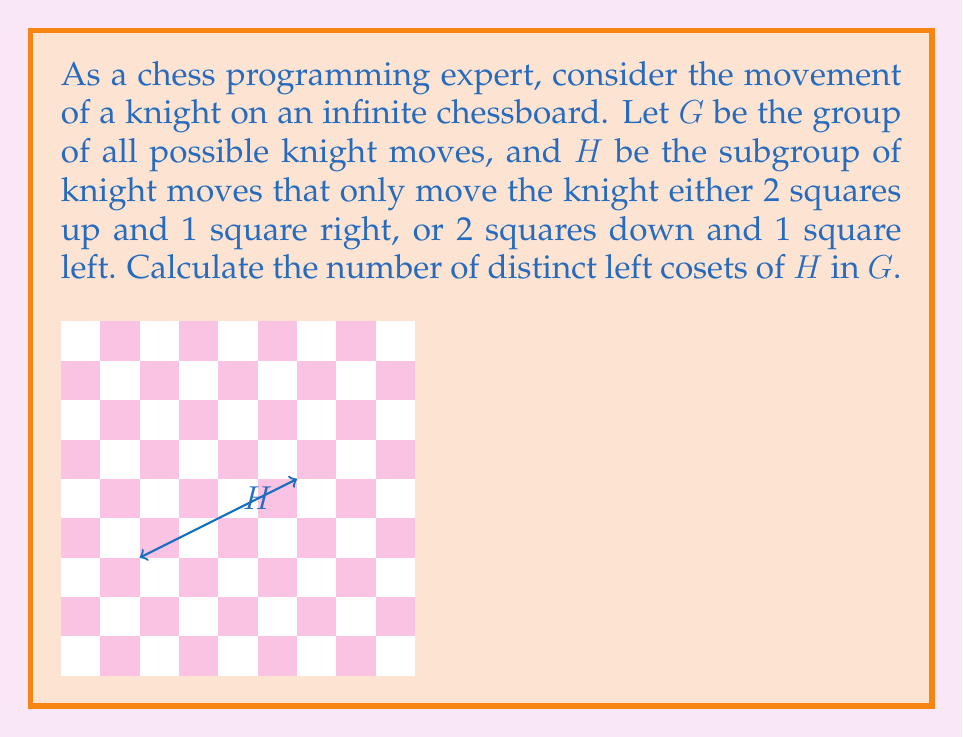Can you answer this question? Let's approach this step-by-step:

1) First, we need to understand the structure of the group G and the subgroup H:
   - G consists of all possible knight moves (8 in total)
   - H consists of only 2 specific moves

2) The number of distinct left cosets is equal to the index of H in G, denoted as [G:H].

3) By Lagrange's theorem, we know that:

   $$[G:H] = \frac{|G|}{|H|}$$

   where |G| is the order of G and |H| is the order of H.

4) Let's calculate |G| and |H|:
   - |G| = 8 (total number of knight moves)
   - |H| = 2 (number of moves in the subgroup)

5) Now we can substitute these values into the formula:

   $$[G:H] = \frac{|G|}{|H|} = \frac{8}{2} = 4$$

6) Therefore, there are 4 distinct left cosets of H in G.

This result means that the knight's movement space can be partitioned into 4 equivalent classes, each represented by one of the cosets. As a chess programmer, this information could be useful for optimizing knight move generation or analysis in your chess engine.
Answer: 4 